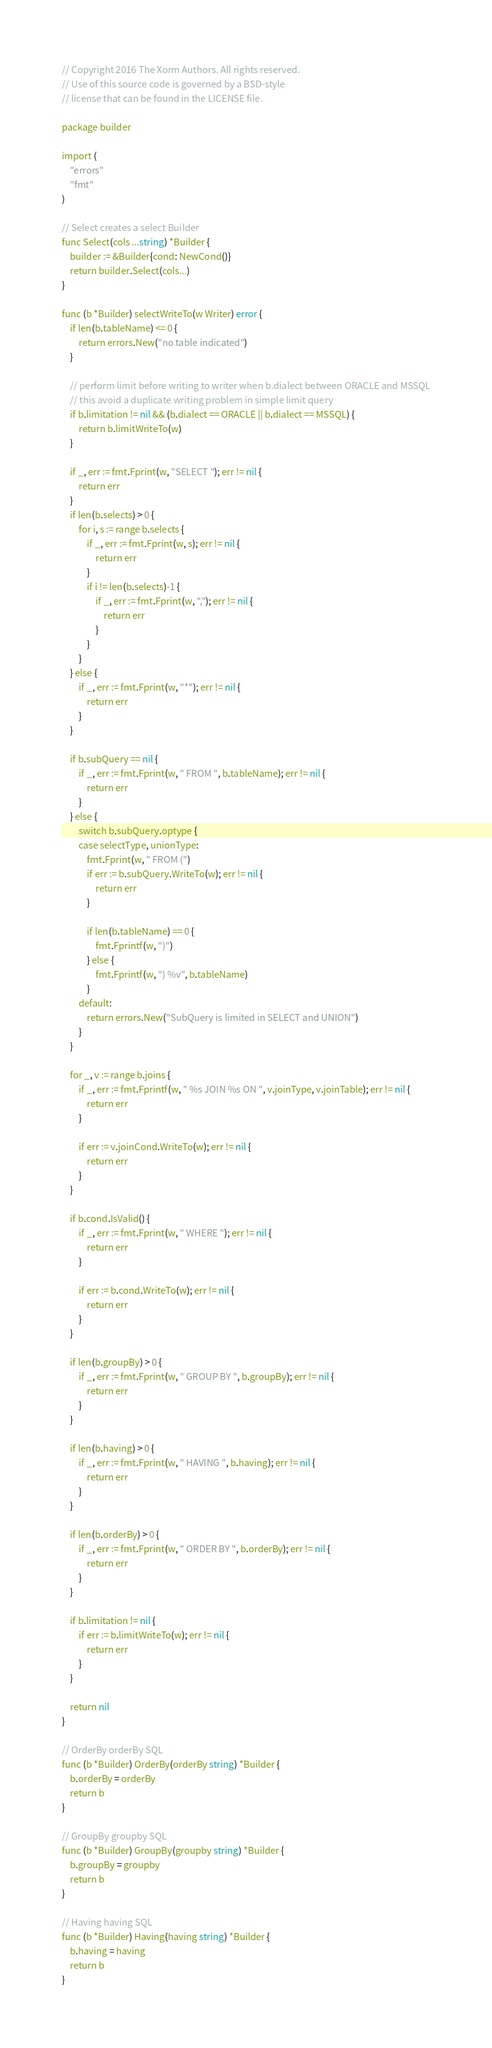Convert code to text. <code><loc_0><loc_0><loc_500><loc_500><_Go_>// Copyright 2016 The Xorm Authors. All rights reserved.
// Use of this source code is governed by a BSD-style
// license that can be found in the LICENSE file.

package builder

import (
	"errors"
	"fmt"
)

// Select creates a select Builder
func Select(cols ...string) *Builder {
	builder := &Builder{cond: NewCond()}
	return builder.Select(cols...)
}

func (b *Builder) selectWriteTo(w Writer) error {
	if len(b.tableName) <= 0 {
		return errors.New("no table indicated")
	}

	// perform limit before writing to writer when b.dialect between ORACLE and MSSQL
	// this avoid a duplicate writing problem in simple limit query
	if b.limitation != nil && (b.dialect == ORACLE || b.dialect == MSSQL) {
		return b.limitWriteTo(w)
	}

	if _, err := fmt.Fprint(w, "SELECT "); err != nil {
		return err
	}
	if len(b.selects) > 0 {
		for i, s := range b.selects {
			if _, err := fmt.Fprint(w, s); err != nil {
				return err
			}
			if i != len(b.selects)-1 {
				if _, err := fmt.Fprint(w, ","); err != nil {
					return err
				}
			}
		}
	} else {
		if _, err := fmt.Fprint(w, "*"); err != nil {
			return err
		}
	}

	if b.subQuery == nil {
		if _, err := fmt.Fprint(w, " FROM ", b.tableName); err != nil {
			return err
		}
	} else {
		switch b.subQuery.optype {
		case selectType, unionType:
			fmt.Fprint(w, " FROM (")
			if err := b.subQuery.WriteTo(w); err != nil {
				return err
			}

			if len(b.tableName) == 0 {
				fmt.Fprintf(w, ")")
			} else {
				fmt.Fprintf(w, ") %v", b.tableName)
			}
		default:
			return errors.New("SubQuery is limited in SELECT and UNION")
		}
	}

	for _, v := range b.joins {
		if _, err := fmt.Fprintf(w, " %s JOIN %s ON ", v.joinType, v.joinTable); err != nil {
			return err
		}

		if err := v.joinCond.WriteTo(w); err != nil {
			return err
		}
	}

	if b.cond.IsValid() {
		if _, err := fmt.Fprint(w, " WHERE "); err != nil {
			return err
		}

		if err := b.cond.WriteTo(w); err != nil {
			return err
		}
	}

	if len(b.groupBy) > 0 {
		if _, err := fmt.Fprint(w, " GROUP BY ", b.groupBy); err != nil {
			return err
		}
	}

	if len(b.having) > 0 {
		if _, err := fmt.Fprint(w, " HAVING ", b.having); err != nil {
			return err
		}
	}

	if len(b.orderBy) > 0 {
		if _, err := fmt.Fprint(w, " ORDER BY ", b.orderBy); err != nil {
			return err
		}
	}

	if b.limitation != nil {
		if err := b.limitWriteTo(w); err != nil {
			return err
		}
	}

	return nil
}

// OrderBy orderBy SQL
func (b *Builder) OrderBy(orderBy string) *Builder {
	b.orderBy = orderBy
	return b
}

// GroupBy groupby SQL
func (b *Builder) GroupBy(groupby string) *Builder {
	b.groupBy = groupby
	return b
}

// Having having SQL
func (b *Builder) Having(having string) *Builder {
	b.having = having
	return b
}
</code> 